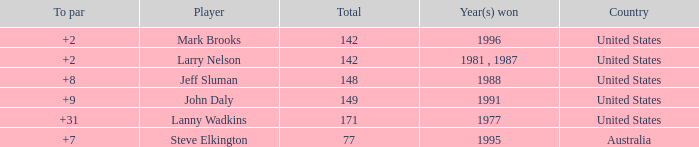Name the To par that has a Year(s) won of 1988 and a Total smaller than 148? None. 